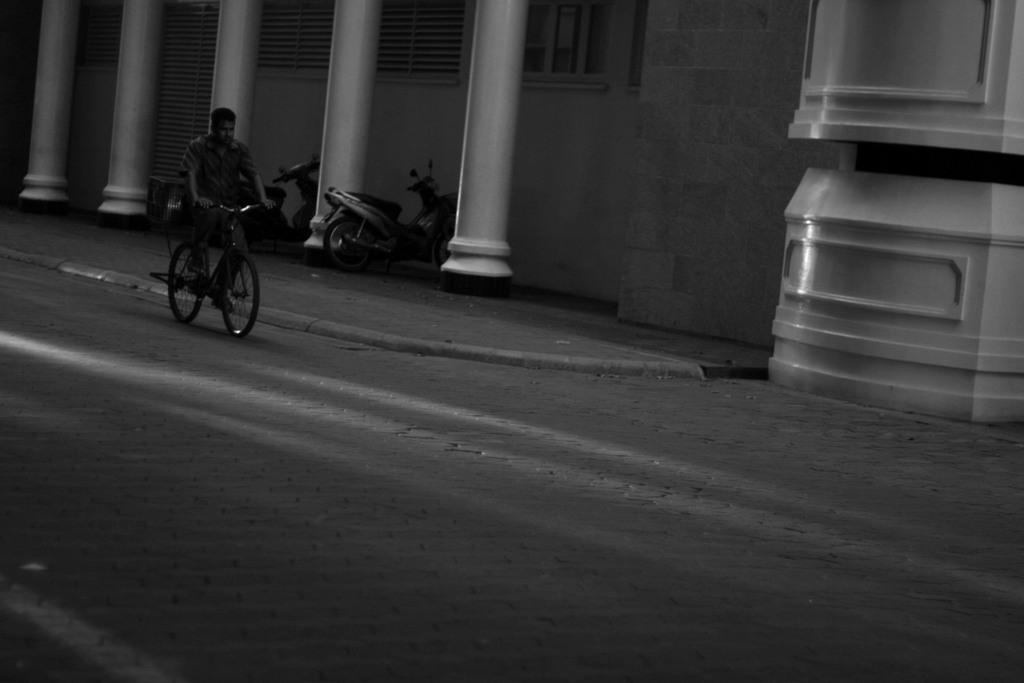What is the man in the image doing? The man is riding a bicycle in the image. What type of structure can be seen in the background? There is a house building with pillars in the image. What vehicles are parked on the path? Motorcycles are parked on the path in the image. Can you describe a feature of the house in the image? There is a window in the house in the image. What sense is the man using to ride the bicycle in the image? The image does not provide information about the man's senses, so we cannot determine which sense he is using to ride the bicycle. 